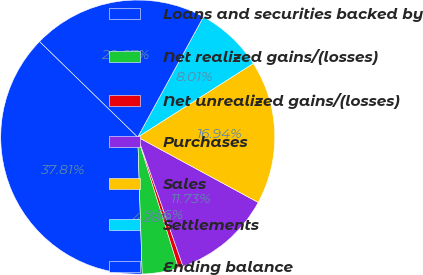Convert chart. <chart><loc_0><loc_0><loc_500><loc_500><pie_chart><fcel>Loans and securities backed by<fcel>Net realized gains/(losses)<fcel>Net unrealized gains/(losses)<fcel>Purchases<fcel>Sales<fcel>Settlements<fcel>Ending balance<nl><fcel>37.81%<fcel>4.28%<fcel>0.56%<fcel>11.73%<fcel>16.94%<fcel>8.01%<fcel>20.67%<nl></chart> 